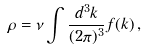<formula> <loc_0><loc_0><loc_500><loc_500>\rho = \nu \int \frac { d ^ { 3 } k } { ( 2 \pi ) ^ { 3 } } f ( k ) \, ,</formula> 